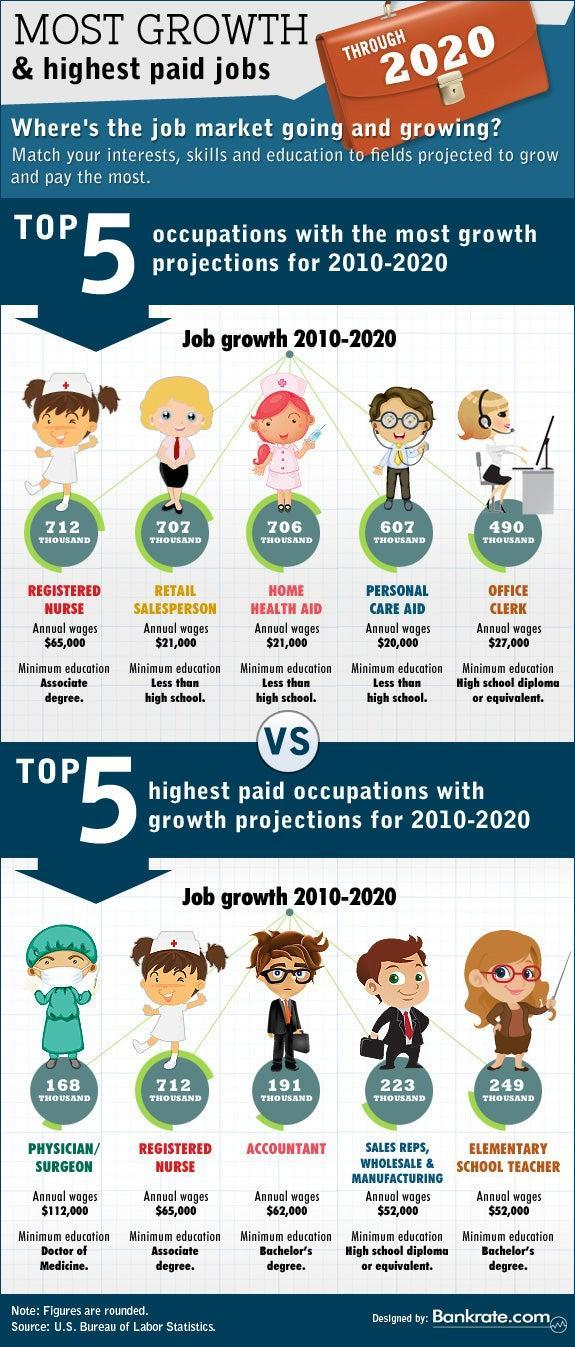Who requires atleast a high school diploma or equivalent for highest paid job?
Answer the question with a short phrase. SALES REPS, WHOLESALE & MANUFACTURING Who receives the lowest annual wages? PERSONAL CARE AID Which job had the most growth during 2010-2020? REGISTERED NURSE 